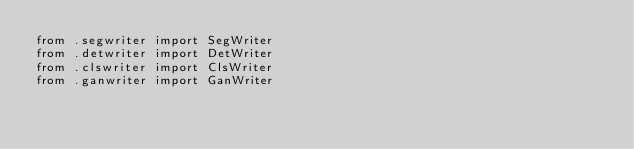Convert code to text. <code><loc_0><loc_0><loc_500><loc_500><_Python_>from .segwriter import SegWriter
from .detwriter import DetWriter
from .clswriter import ClsWriter
from .ganwriter import GanWriter</code> 